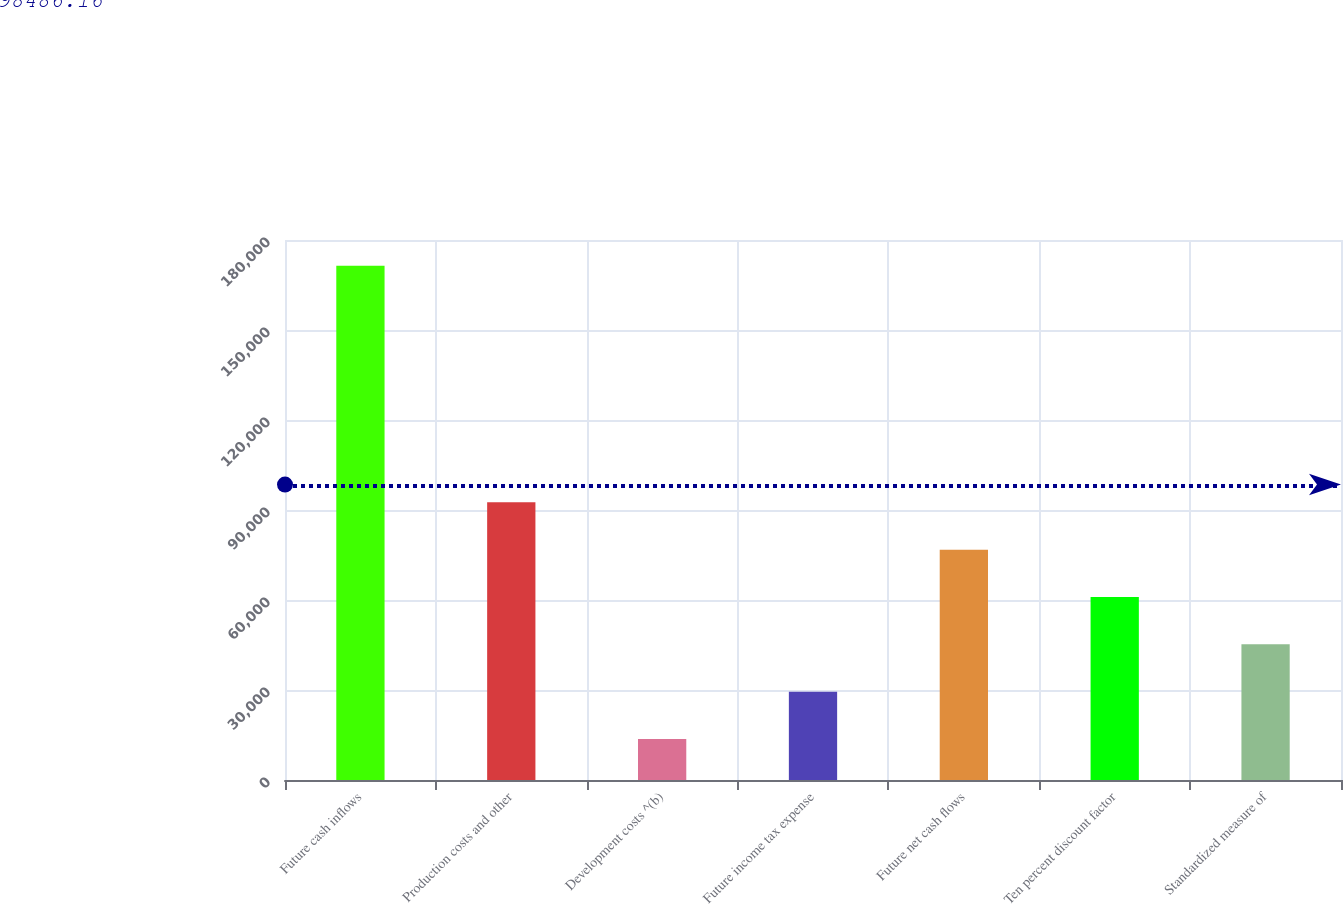Convert chart. <chart><loc_0><loc_0><loc_500><loc_500><bar_chart><fcel>Future cash inflows<fcel>Production costs and other<fcel>Development costs ^(b)<fcel>Future income tax expense<fcel>Future net cash flows<fcel>Ten percent discount factor<fcel>Standardized measure of<nl><fcel>171456<fcel>92558<fcel>13660<fcel>29439.6<fcel>76778.4<fcel>60998.8<fcel>45219.2<nl></chart> 